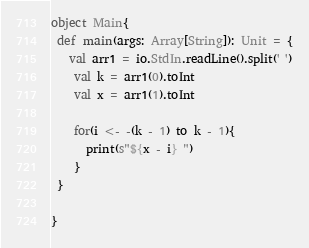Convert code to text. <code><loc_0><loc_0><loc_500><loc_500><_Scala_>object Main{
 def main(args: Array[String]): Unit = {
   val arr1 = io.StdIn.readLine().split(' ')
    val k = arr1(0).toInt
    val x = arr1(1).toInt

    for(i <- -(k - 1) to k - 1){
      print(s"${x - i} ")
    }
 }
  
}</code> 